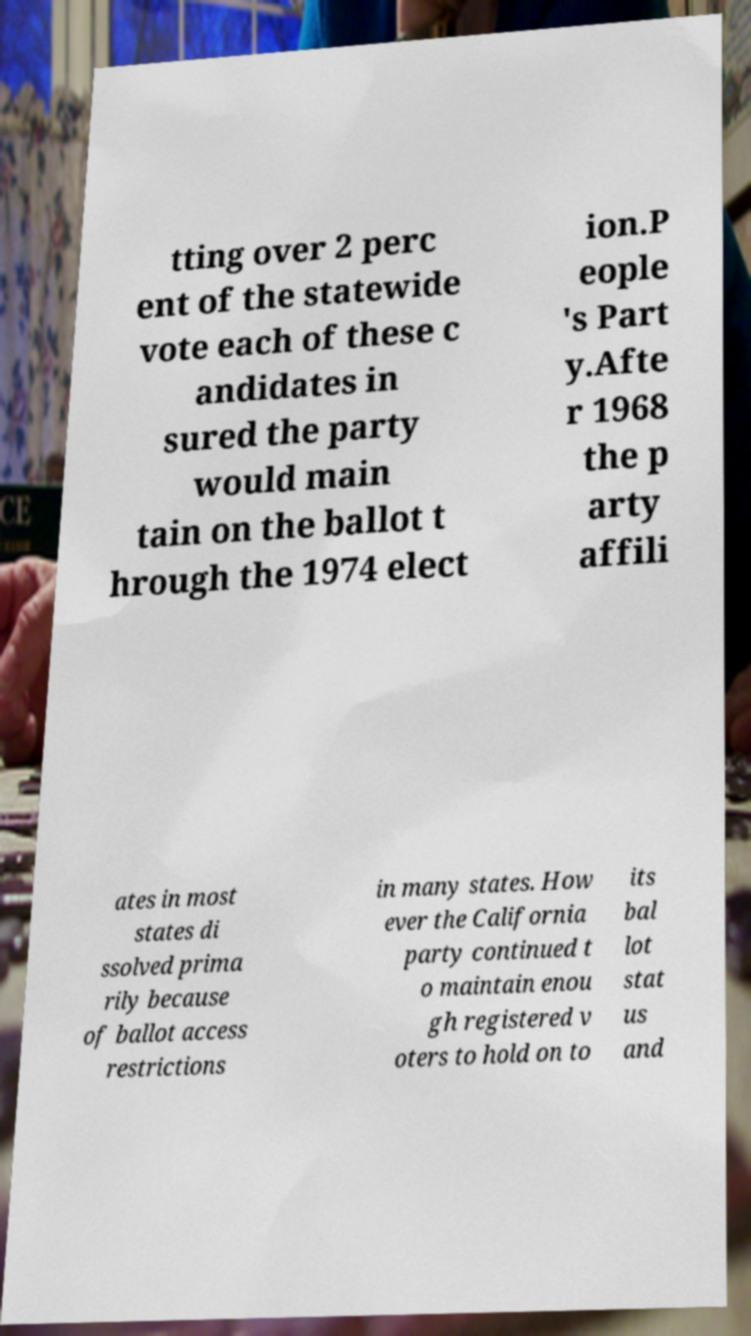I need the written content from this picture converted into text. Can you do that? tting over 2 perc ent of the statewide vote each of these c andidates in sured the party would main tain on the ballot t hrough the 1974 elect ion.P eople 's Part y.Afte r 1968 the p arty affili ates in most states di ssolved prima rily because of ballot access restrictions in many states. How ever the California party continued t o maintain enou gh registered v oters to hold on to its bal lot stat us and 